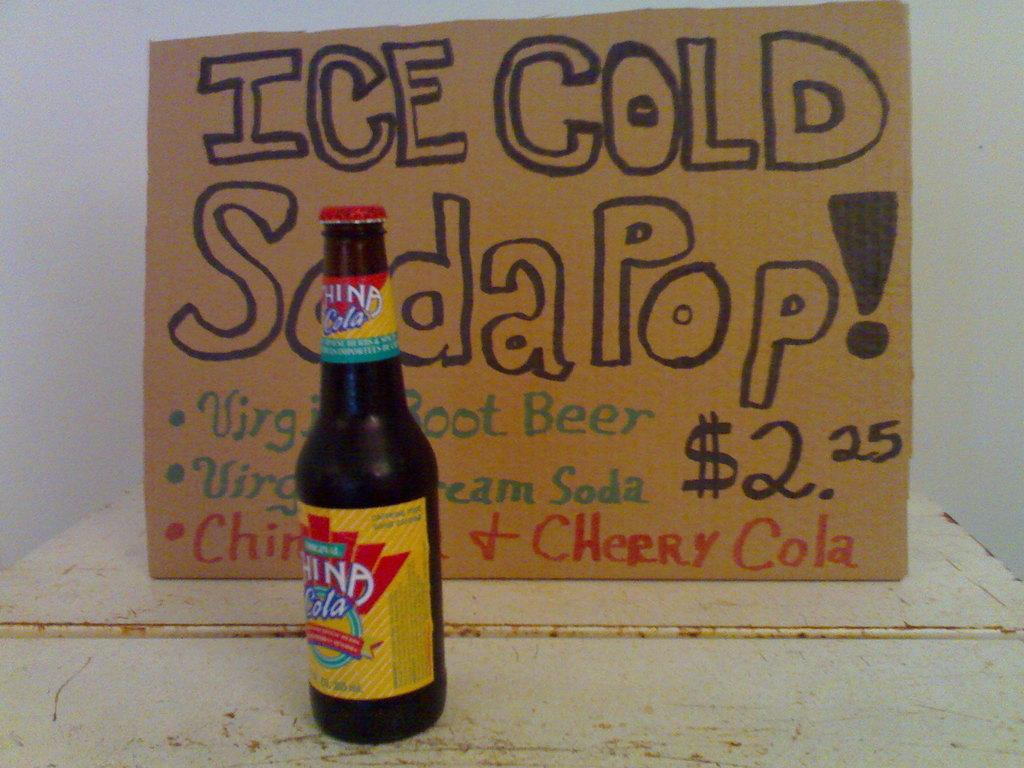Provide a one-sentence caption for the provided image. An artistic hand written sign saying Ice Cold Soda Pop  with a pop bottle next to it. 